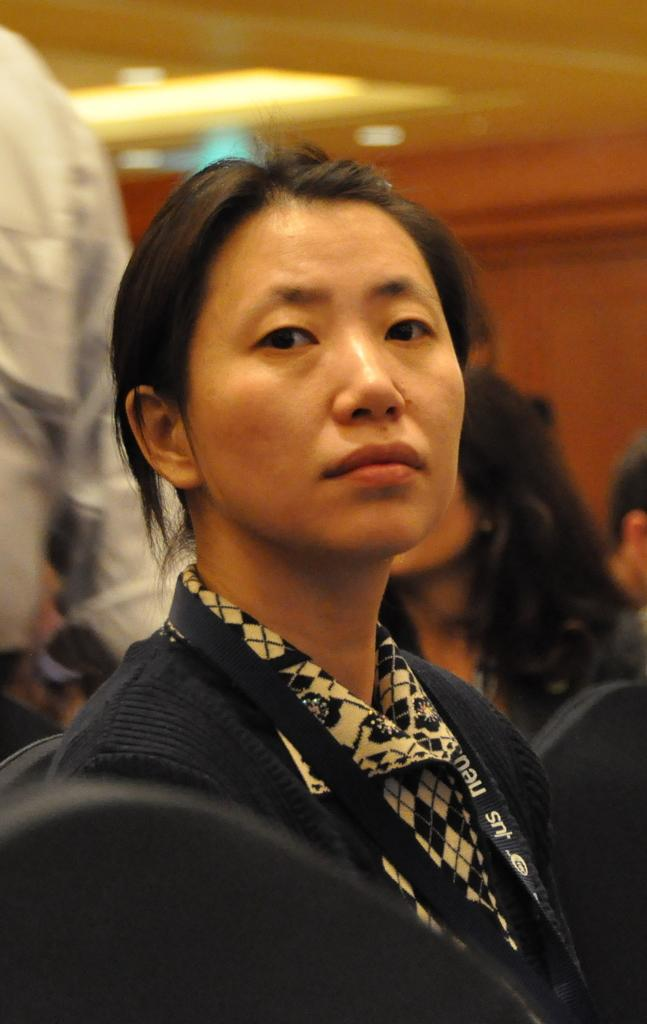Who is the main subject in the picture? There is a woman in the picture. What is the woman wearing in the image? The woman is wearing a coat and an ID card. What is the woman doing in the image? The woman is looking towards the camera. How is the background of the woman depicted in the image? The background of the woman is blurred. What force is causing the woman to move in the image? There is no indication of movement in the image, and therefore no force can be identified. 